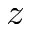Convert formula to latex. <formula><loc_0><loc_0><loc_500><loc_500>z</formula> 